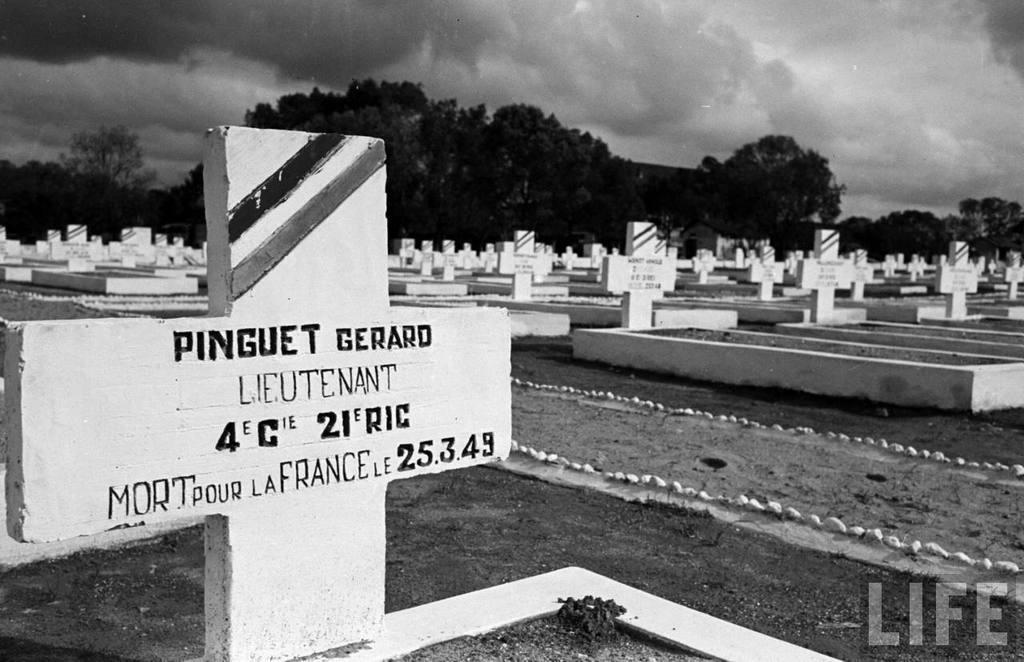How would you summarize this image in a sentence or two? This picture is in black and white. This picture, we see graves or headstones. There are trees in the background. At the top of the picture, we see the sky and the clouds. This picture is clicked in the graveyard. 